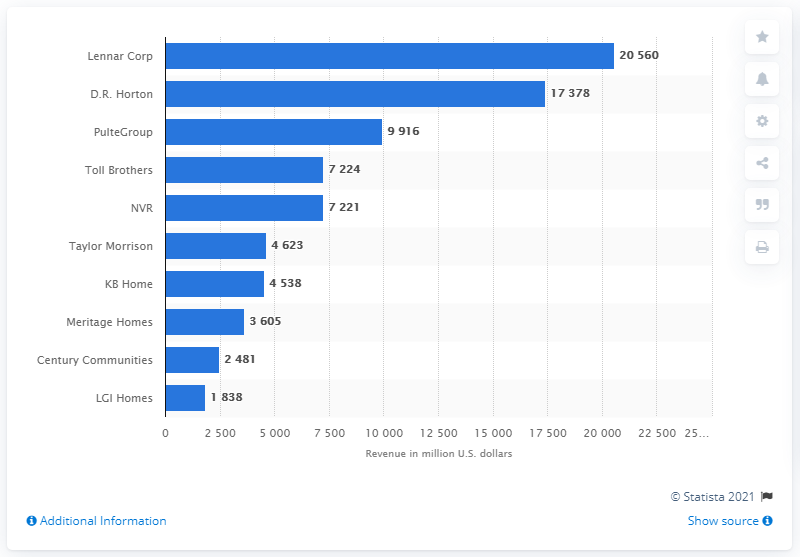Draw attention to some important aspects in this diagram. In 2019, Lennar Corp. was the leading home builder in the United States in terms of gross revenue. In 2019, Lennar Corp reported earnings of 205.6 million dollars. 